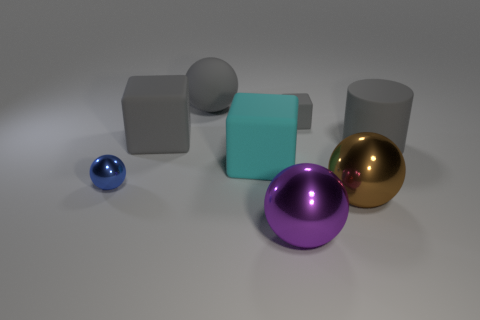There is a gray matte cube in front of the small rubber cube; is it the same size as the shiny sphere that is in front of the big brown shiny object?
Your response must be concise. Yes. What number of gray cylinders are made of the same material as the tiny gray cube?
Your response must be concise. 1. What color is the rubber cylinder?
Ensure brevity in your answer.  Gray. There is a big purple metallic object; are there any small objects in front of it?
Offer a terse response. No. Is the color of the small rubber thing the same as the rubber ball?
Ensure brevity in your answer.  Yes. What number of large spheres are the same color as the tiny rubber object?
Offer a terse response. 1. What is the size of the cyan rubber thing that is left of the shiny object in front of the large brown metallic sphere?
Offer a very short reply. Large. The small gray thing is what shape?
Your answer should be very brief. Cube. There is a block that is on the left side of the cyan block; what material is it?
Offer a terse response. Rubber. There is a shiny object that is on the left side of the big matte block to the right of the ball that is behind the small blue metallic ball; what color is it?
Provide a short and direct response. Blue. 